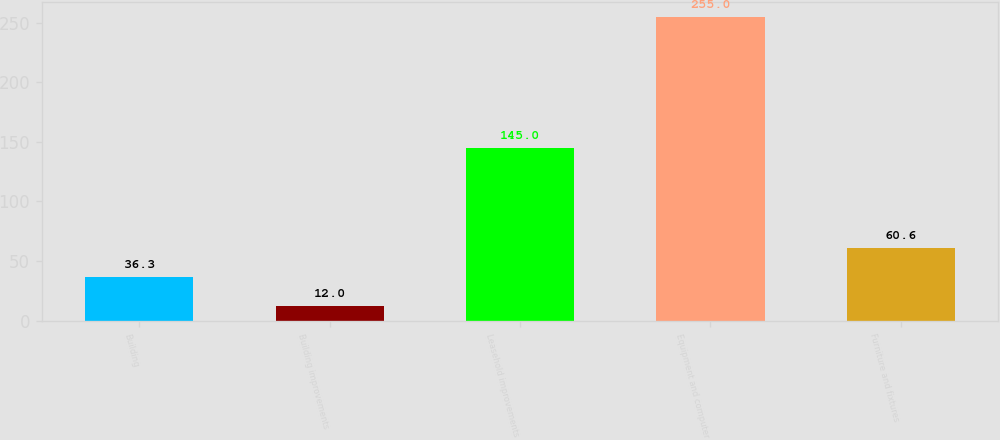Convert chart to OTSL. <chart><loc_0><loc_0><loc_500><loc_500><bar_chart><fcel>Building<fcel>Building improvements<fcel>Leasehold improvements<fcel>Equipment and computer<fcel>Furniture and fixtures<nl><fcel>36.3<fcel>12<fcel>145<fcel>255<fcel>60.6<nl></chart> 